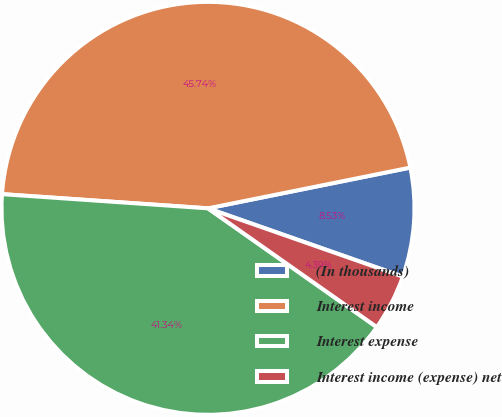Convert chart to OTSL. <chart><loc_0><loc_0><loc_500><loc_500><pie_chart><fcel>(In thousands)<fcel>Interest income<fcel>Interest expense<fcel>Interest income (expense) net<nl><fcel>8.53%<fcel>45.74%<fcel>41.34%<fcel>4.39%<nl></chart> 